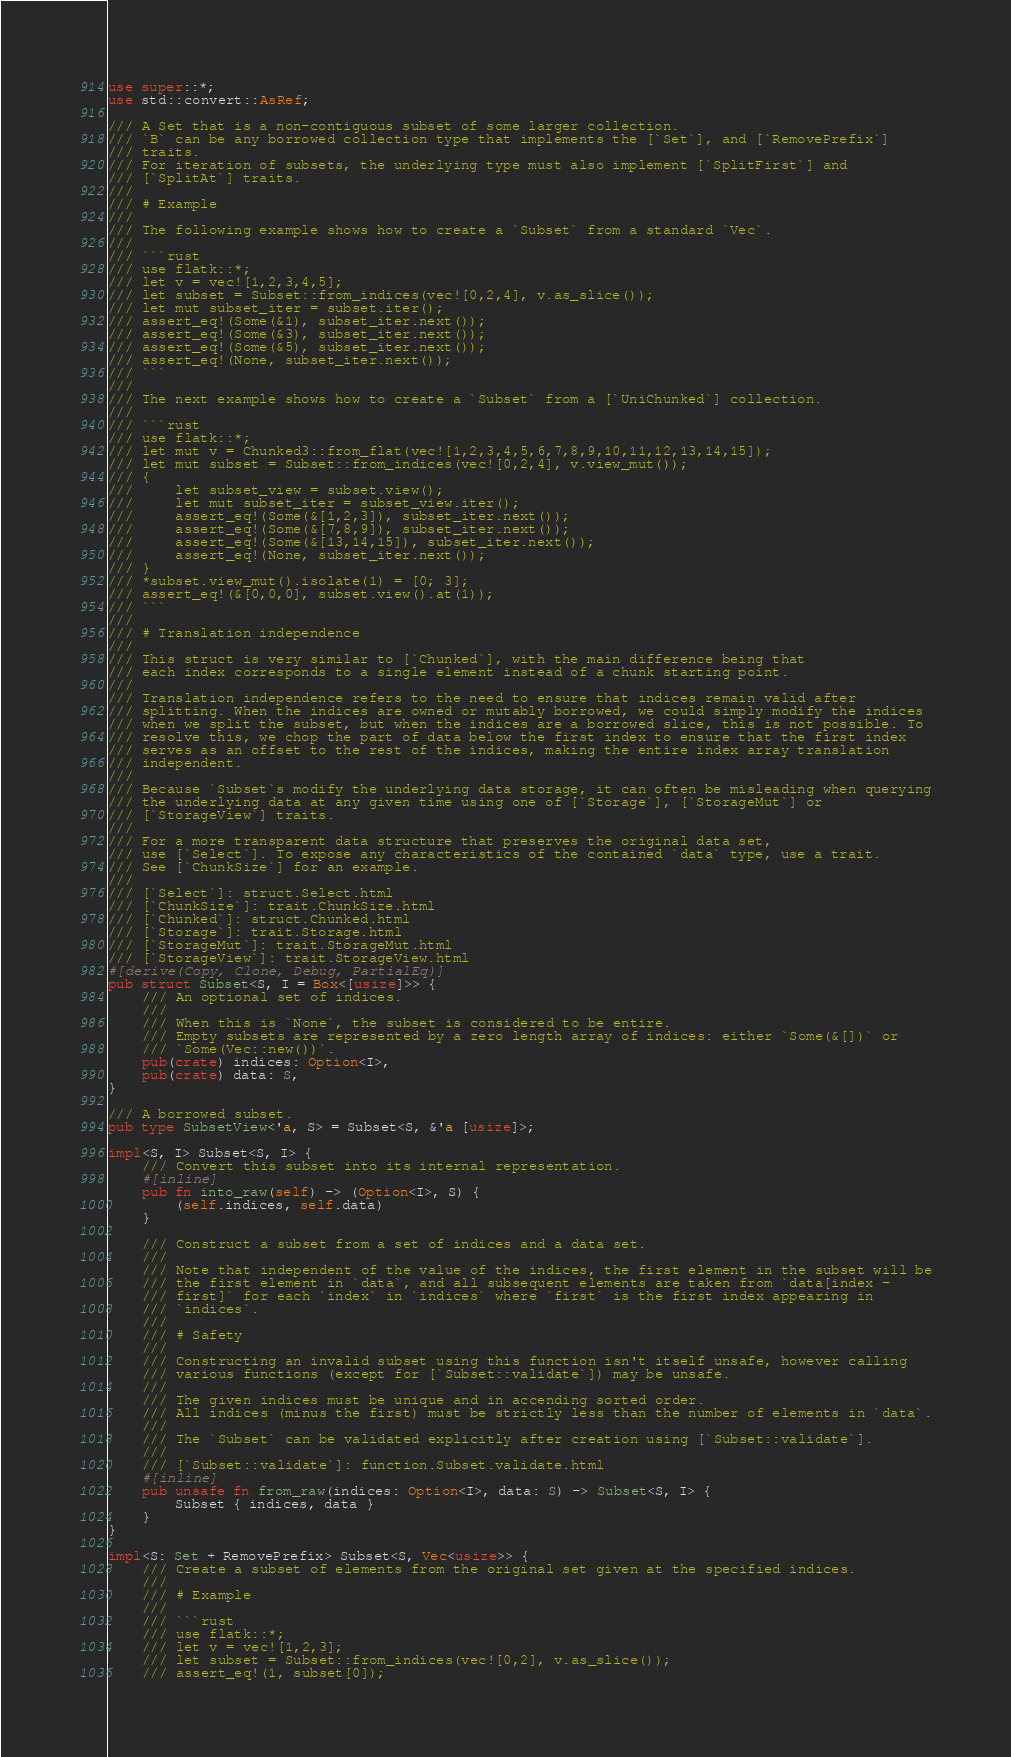Convert code to text. <code><loc_0><loc_0><loc_500><loc_500><_Rust_>use super::*;
use std::convert::AsRef;

/// A Set that is a non-contiguous subset of some larger collection.
/// `B` can be any borrowed collection type that implements the [`Set`], and [`RemovePrefix`]
/// traits.
/// For iteration of subsets, the underlying type must also implement [`SplitFirst`] and
/// [`SplitAt`] traits.
///
/// # Example
///
/// The following example shows how to create a `Subset` from a standard `Vec`.
///
/// ```rust
/// use flatk::*;
/// let v = vec![1,2,3,4,5];
/// let subset = Subset::from_indices(vec![0,2,4], v.as_slice());
/// let mut subset_iter = subset.iter();
/// assert_eq!(Some(&1), subset_iter.next());
/// assert_eq!(Some(&3), subset_iter.next());
/// assert_eq!(Some(&5), subset_iter.next());
/// assert_eq!(None, subset_iter.next());
/// ```
///
/// The next example shows how to create a `Subset` from a [`UniChunked`] collection.
///
/// ```rust
/// use flatk::*;
/// let mut v = Chunked3::from_flat(vec![1,2,3,4,5,6,7,8,9,10,11,12,13,14,15]);
/// let mut subset = Subset::from_indices(vec![0,2,4], v.view_mut());
/// {
///     let subset_view = subset.view();
///     let mut subset_iter = subset_view.iter();
///     assert_eq!(Some(&[1,2,3]), subset_iter.next());
///     assert_eq!(Some(&[7,8,9]), subset_iter.next());
///     assert_eq!(Some(&[13,14,15]), subset_iter.next());
///     assert_eq!(None, subset_iter.next());
/// }
/// *subset.view_mut().isolate(1) = [0; 3];
/// assert_eq!(&[0,0,0], subset.view().at(1));
/// ```
///
/// # Translation independence
///
/// This struct is very similar to [`Chunked`], with the main difference being that
/// each index corresponds to a single element instead of a chunk starting point.
///
/// Translation independence refers to the need to ensure that indices remain valid after
/// splitting. When the indices are owned or mutably borrowed, we could simply modify the indices
/// when we split the subset, but when the indices are a borrowed slice, this is not possible. To
/// resolve this, we chop the part of data below the first index to ensure that the first index
/// serves as an offset to the rest of the indices, making the entire index array translation
/// independent.
///
/// Because `Subset`s modify the underlying data storage, it can often be misleading when querying
/// the underlying data at any given time using one of [`Storage`], [`StorageMut`] or
/// [`StorageView`] traits.
///
/// For a more transparent data structure that preserves the original data set,
/// use [`Select`]. To expose any characteristics of the contained `data` type, use a trait.
/// See [`ChunkSize`] for an example.
///
/// [`Select`]: struct.Select.html
/// [`ChunkSize`]: trait.ChunkSize.html
/// [`Chunked`]: struct.Chunked.html
/// [`Storage`]: trait.Storage.html
/// [`StorageMut`]: trait.StorageMut.html
/// [`StorageView`]: trait.StorageView.html
#[derive(Copy, Clone, Debug, PartialEq)]
pub struct Subset<S, I = Box<[usize]>> {
    /// An optional set of indices.
    ///
    /// When this is `None`, the subset is considered to be entire.
    /// Empty subsets are represented by a zero length array of indices: either `Some(&[])` or
    /// `Some(Vec::new())`.
    pub(crate) indices: Option<I>,
    pub(crate) data: S,
}

/// A borrowed subset.
pub type SubsetView<'a, S> = Subset<S, &'a [usize]>;

impl<S, I> Subset<S, I> {
    /// Convert this subset into its internal representation.
    #[inline]
    pub fn into_raw(self) -> (Option<I>, S) {
        (self.indices, self.data)
    }

    /// Construct a subset from a set of indices and a data set.
    ///
    /// Note that independent of the value of the indices, the first element in the subset will be
    /// the first element in `data`, and all subsequent elements are taken from `data[index -
    /// first]` for each `index` in `indices` where `first` is the first index appearing in
    /// `indices`.
    ///
    /// # Safety
    ///
    /// Constructing an invalid subset using this function isn't itself unsafe, however calling
    /// various functions (except for [`Subset::validate`]) may be unsafe.
    ///
    /// The given indices must be unique and in accending sorted order.
    /// All indices (minus the first) must be strictly less than the number of elements in `data`.
    ///
    /// The `Subset` can be validated explicitly after creation using [`Subset::validate`].
    ///
    /// [`Subset::validate`]: function.Subset.validate.html
    #[inline]
    pub unsafe fn from_raw(indices: Option<I>, data: S) -> Subset<S, I> {
        Subset { indices, data }
    }
}

impl<S: Set + RemovePrefix> Subset<S, Vec<usize>> {
    /// Create a subset of elements from the original set given at the specified indices.
    ///
    /// # Example
    ///
    /// ```rust
    /// use flatk::*;
    /// let v = vec![1,2,3];
    /// let subset = Subset::from_indices(vec![0,2], v.as_slice());
    /// assert_eq!(1, subset[0]);</code> 